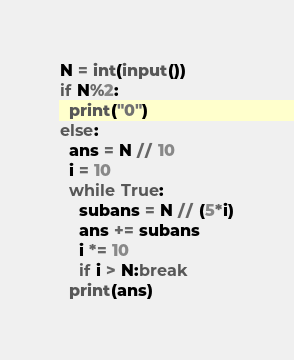Convert code to text. <code><loc_0><loc_0><loc_500><loc_500><_Python_>N = int(input())
if N%2:
  print("0")
else:
  ans = N // 10
  i = 10
  while True:
    subans = N // (5*i)
    ans += subans
    i *= 10
    if i > N:break
  print(ans)</code> 